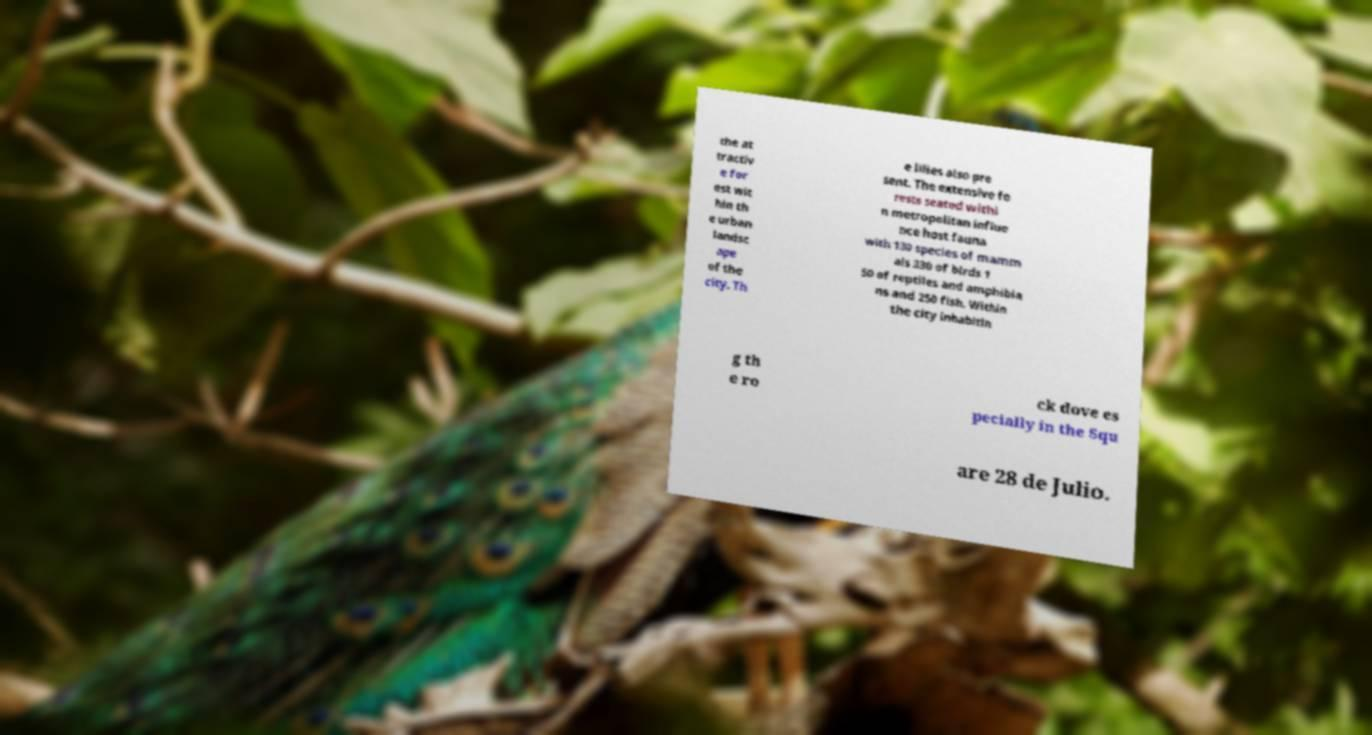Please identify and transcribe the text found in this image. the at tractiv e for est wit hin th e urban landsc ape of the city. Th e lilies also pre sent. The extensive fo rests seated withi n metropolitan influe nce host fauna with 130 species of mamm als 330 of birds 1 50 of reptiles and amphibia ns and 250 fish. Within the city inhabitin g th e ro ck dove es pecially in the Squ are 28 de Julio. 